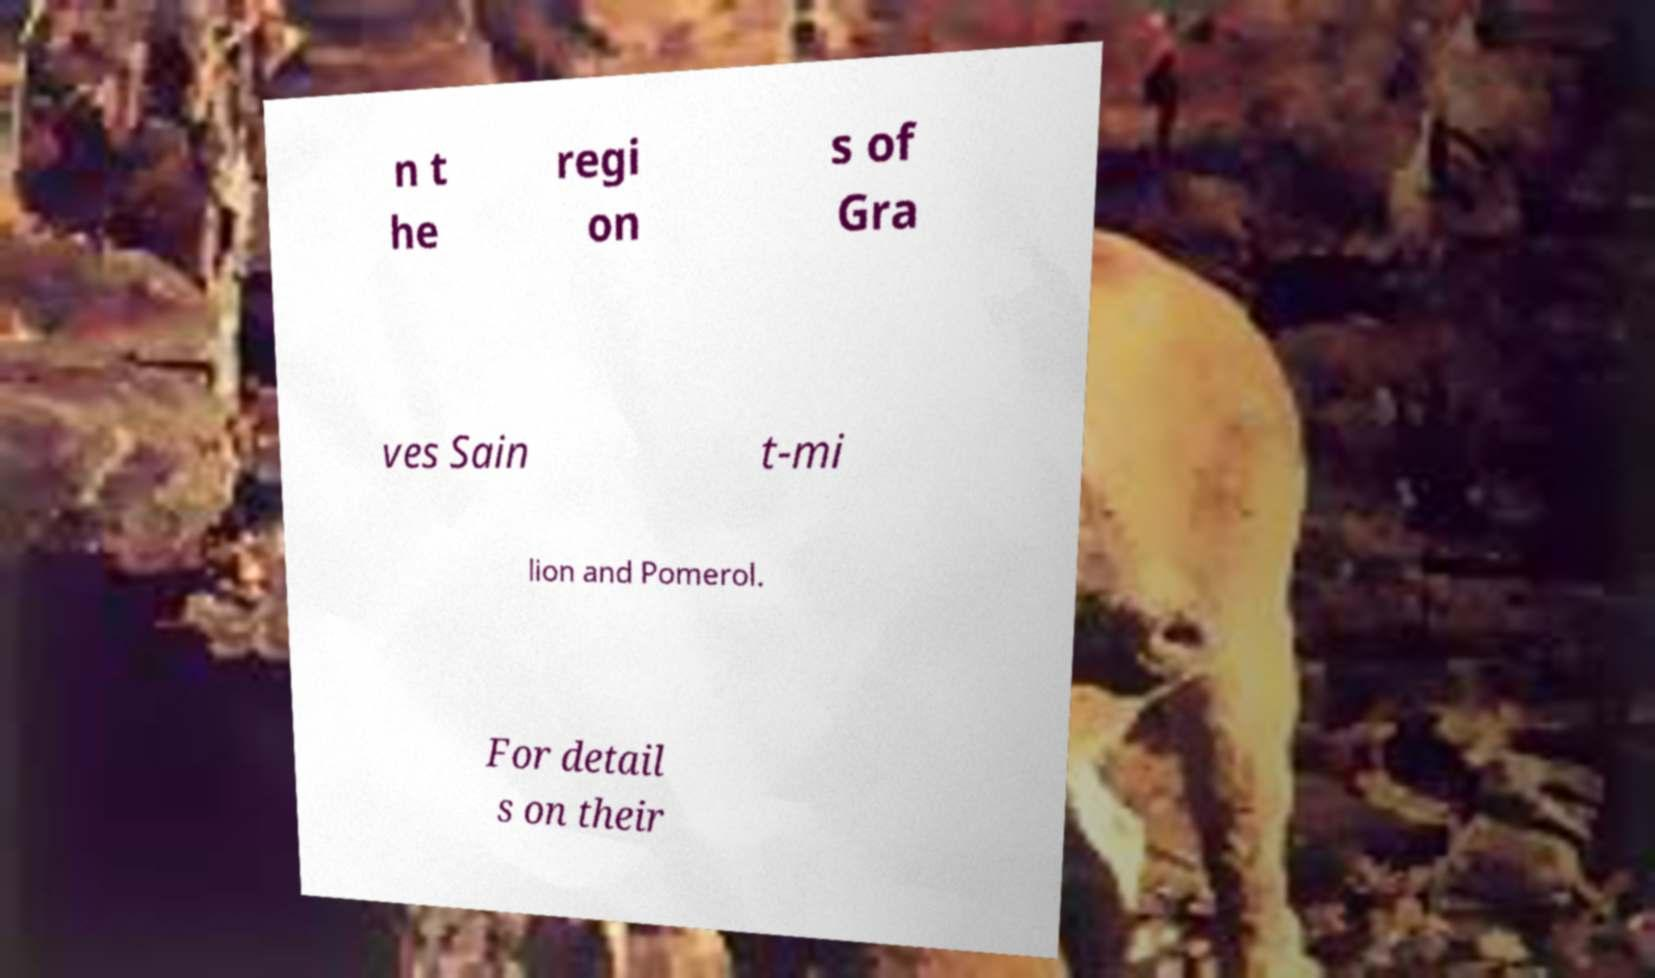For documentation purposes, I need the text within this image transcribed. Could you provide that? n t he regi on s of Gra ves Sain t-mi lion and Pomerol. For detail s on their 